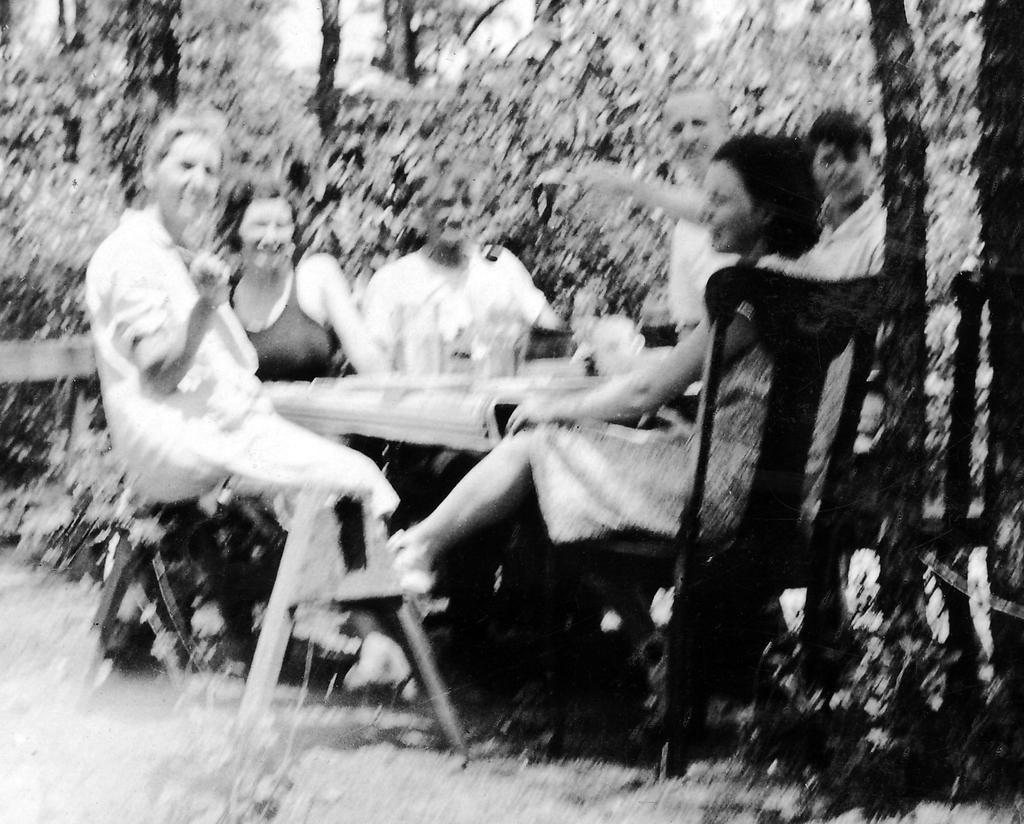How many people are in the image? There is a group of people in the image, but the exact number is not specified. What are the people doing in the image? The people are sitting around a table in the image. What type of turkey is being served at the table in the image? There is no turkey present in the image; the people are simply sitting around a table. 